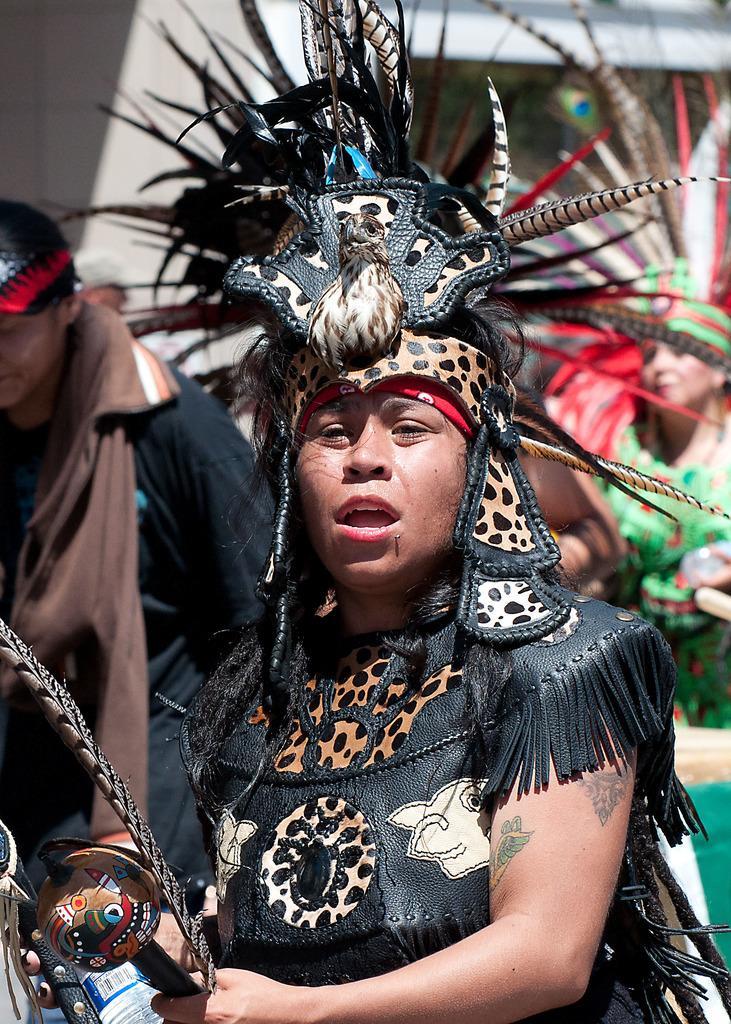Can you describe this image briefly? In this image we can see three persons, among them two persons are in costume and holding the objects and in the background it looks like a building. 